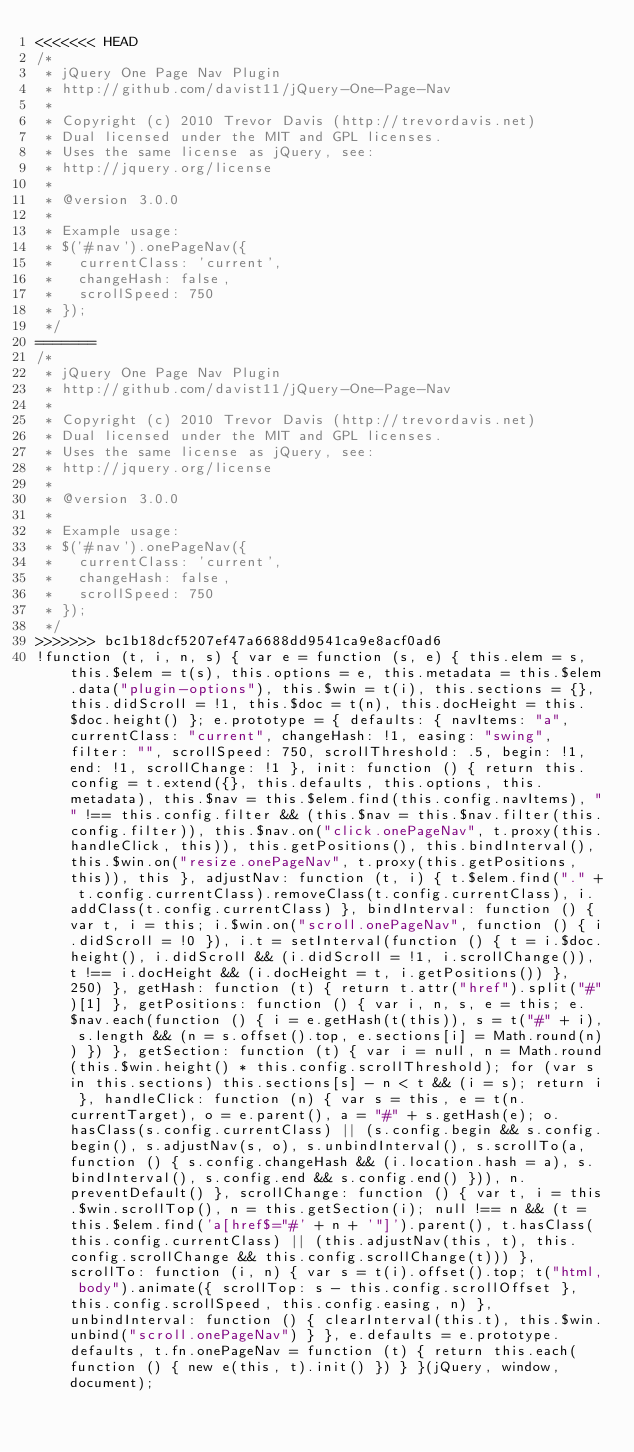<code> <loc_0><loc_0><loc_500><loc_500><_JavaScript_><<<<<<< HEAD
/*
 * jQuery One Page Nav Plugin
 * http://github.com/davist11/jQuery-One-Page-Nav
 *
 * Copyright (c) 2010 Trevor Davis (http://trevordavis.net)
 * Dual licensed under the MIT and GPL licenses.
 * Uses the same license as jQuery, see:
 * http://jquery.org/license
 *
 * @version 3.0.0
 *
 * Example usage:
 * $('#nav').onePageNav({
 *   currentClass: 'current',
 *   changeHash: false,
 *   scrollSpeed: 750
 * });
 */
=======
/*
 * jQuery One Page Nav Plugin
 * http://github.com/davist11/jQuery-One-Page-Nav
 *
 * Copyright (c) 2010 Trevor Davis (http://trevordavis.net)
 * Dual licensed under the MIT and GPL licenses.
 * Uses the same license as jQuery, see:
 * http://jquery.org/license
 *
 * @version 3.0.0
 *
 * Example usage:
 * $('#nav').onePageNav({
 *   currentClass: 'current',
 *   changeHash: false,
 *   scrollSpeed: 750
 * });
 */
>>>>>>> bc1b18dcf5207ef47a6688dd9541ca9e8acf0ad6
!function (t, i, n, s) { var e = function (s, e) { this.elem = s, this.$elem = t(s), this.options = e, this.metadata = this.$elem.data("plugin-options"), this.$win = t(i), this.sections = {}, this.didScroll = !1, this.$doc = t(n), this.docHeight = this.$doc.height() }; e.prototype = { defaults: { navItems: "a", currentClass: "current", changeHash: !1, easing: "swing", filter: "", scrollSpeed: 750, scrollThreshold: .5, begin: !1, end: !1, scrollChange: !1 }, init: function () { return this.config = t.extend({}, this.defaults, this.options, this.metadata), this.$nav = this.$elem.find(this.config.navItems), "" !== this.config.filter && (this.$nav = this.$nav.filter(this.config.filter)), this.$nav.on("click.onePageNav", t.proxy(this.handleClick, this)), this.getPositions(), this.bindInterval(), this.$win.on("resize.onePageNav", t.proxy(this.getPositions, this)), this }, adjustNav: function (t, i) { t.$elem.find("." + t.config.currentClass).removeClass(t.config.currentClass), i.addClass(t.config.currentClass) }, bindInterval: function () { var t, i = this; i.$win.on("scroll.onePageNav", function () { i.didScroll = !0 }), i.t = setInterval(function () { t = i.$doc.height(), i.didScroll && (i.didScroll = !1, i.scrollChange()), t !== i.docHeight && (i.docHeight = t, i.getPositions()) }, 250) }, getHash: function (t) { return t.attr("href").split("#")[1] }, getPositions: function () { var i, n, s, e = this; e.$nav.each(function () { i = e.getHash(t(this)), s = t("#" + i), s.length && (n = s.offset().top, e.sections[i] = Math.round(n)) }) }, getSection: function (t) { var i = null, n = Math.round(this.$win.height() * this.config.scrollThreshold); for (var s in this.sections) this.sections[s] - n < t && (i = s); return i }, handleClick: function (n) { var s = this, e = t(n.currentTarget), o = e.parent(), a = "#" + s.getHash(e); o.hasClass(s.config.currentClass) || (s.config.begin && s.config.begin(), s.adjustNav(s, o), s.unbindInterval(), s.scrollTo(a, function () { s.config.changeHash && (i.location.hash = a), s.bindInterval(), s.config.end && s.config.end() })), n.preventDefault() }, scrollChange: function () { var t, i = this.$win.scrollTop(), n = this.getSection(i); null !== n && (t = this.$elem.find('a[href$="#' + n + '"]').parent(), t.hasClass(this.config.currentClass) || (this.adjustNav(this, t), this.config.scrollChange && this.config.scrollChange(t))) }, scrollTo: function (i, n) { var s = t(i).offset().top; t("html, body").animate({ scrollTop: s - this.config.scrollOffset }, this.config.scrollSpeed, this.config.easing, n) }, unbindInterval: function () { clearInterval(this.t), this.$win.unbind("scroll.onePageNav") } }, e.defaults = e.prototype.defaults, t.fn.onePageNav = function (t) { return this.each(function () { new e(this, t).init() }) } }(jQuery, window, document);</code> 